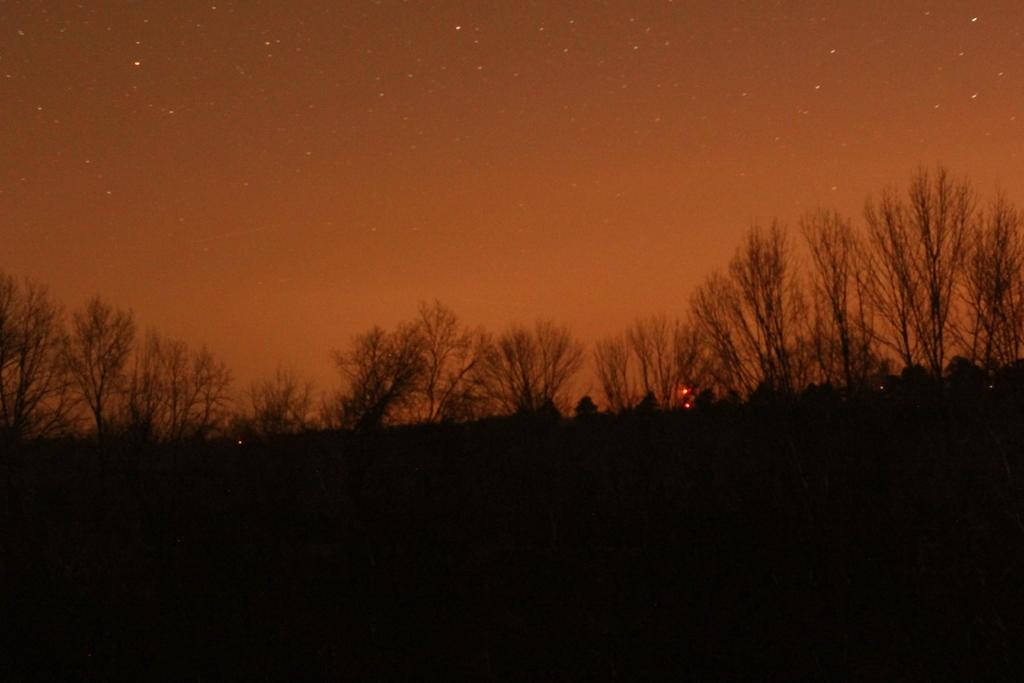What type of vegetation can be seen in the image? There are plants and trees in the image. What is visible at the top of the image? The sky is visible at the top of the image. How would you describe the lighting in the image? The bottom part of the image appears to be dark. How many matches are being lit in the image? There are no matches present in the image. Whose birthday is being celebrated in the image? There is no indication of a birthday celebration in the image. 